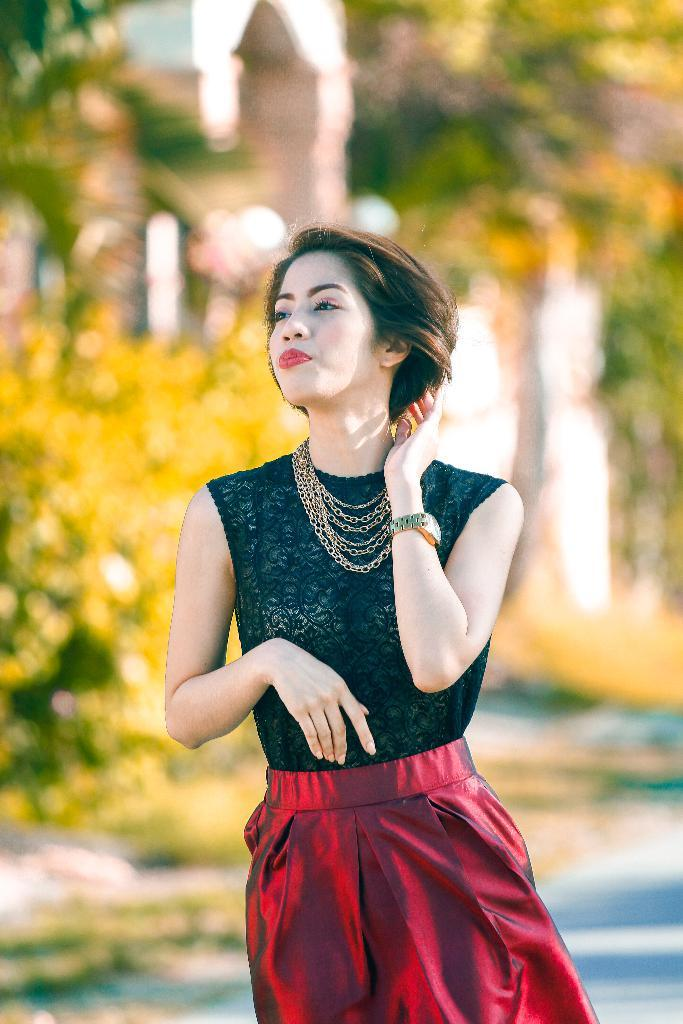What is the main subject of the image? There is a woman in the image. Where is the woman located in relation to the image? The woman is standing in the foreground. What is the woman wearing? The woman is wearing a black and red dress. What can be seen in the background of the image? There is greenery in the background of the image. How does the woman attract the flock of birds in the image? There are no birds present in the image, so the woman cannot attract a flock of birds. 